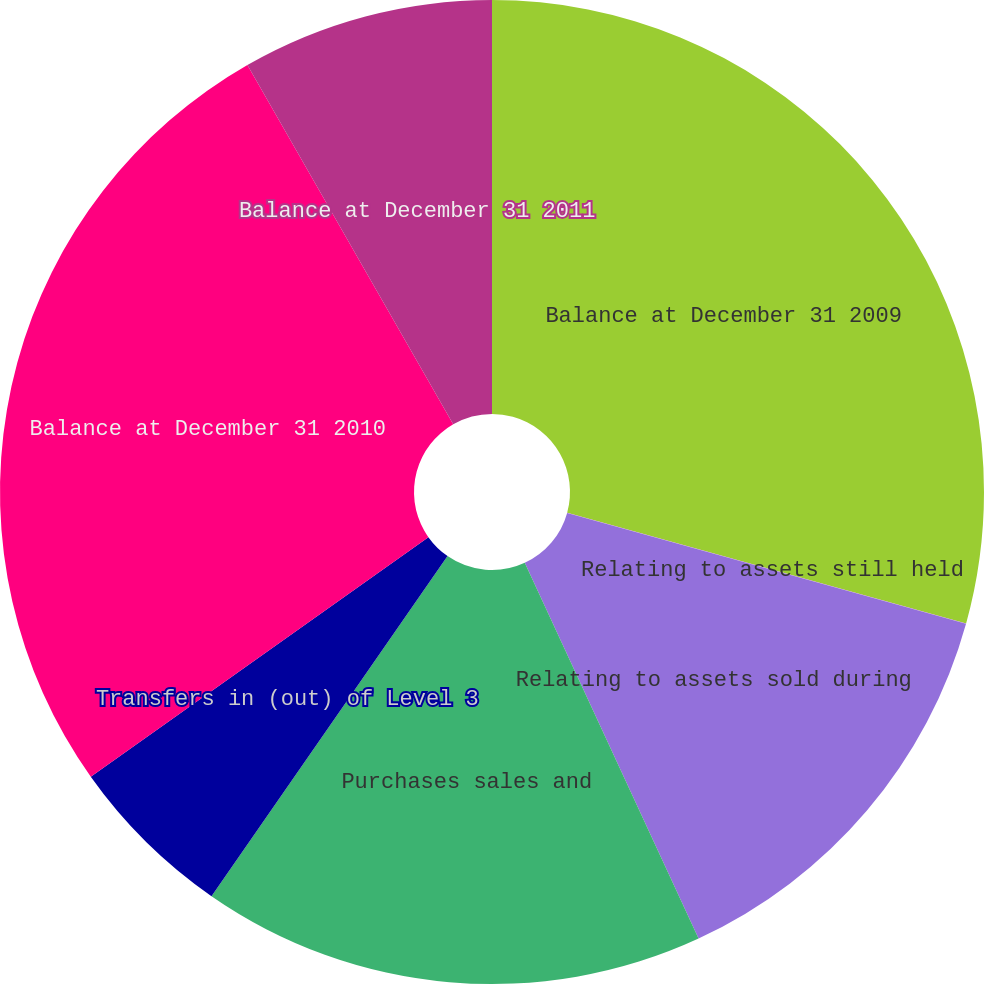<chart> <loc_0><loc_0><loc_500><loc_500><pie_chart><fcel>Balance at December 31 2009<fcel>Relating to assets still held<fcel>Relating to assets sold during<fcel>Purchases sales and<fcel>Transfers in (out) of Level 3<fcel>Balance at December 31 2010<fcel>Balance at December 31 2011<nl><fcel>29.3%<fcel>0.01%<fcel>13.79%<fcel>16.55%<fcel>5.52%<fcel>26.54%<fcel>8.28%<nl></chart> 